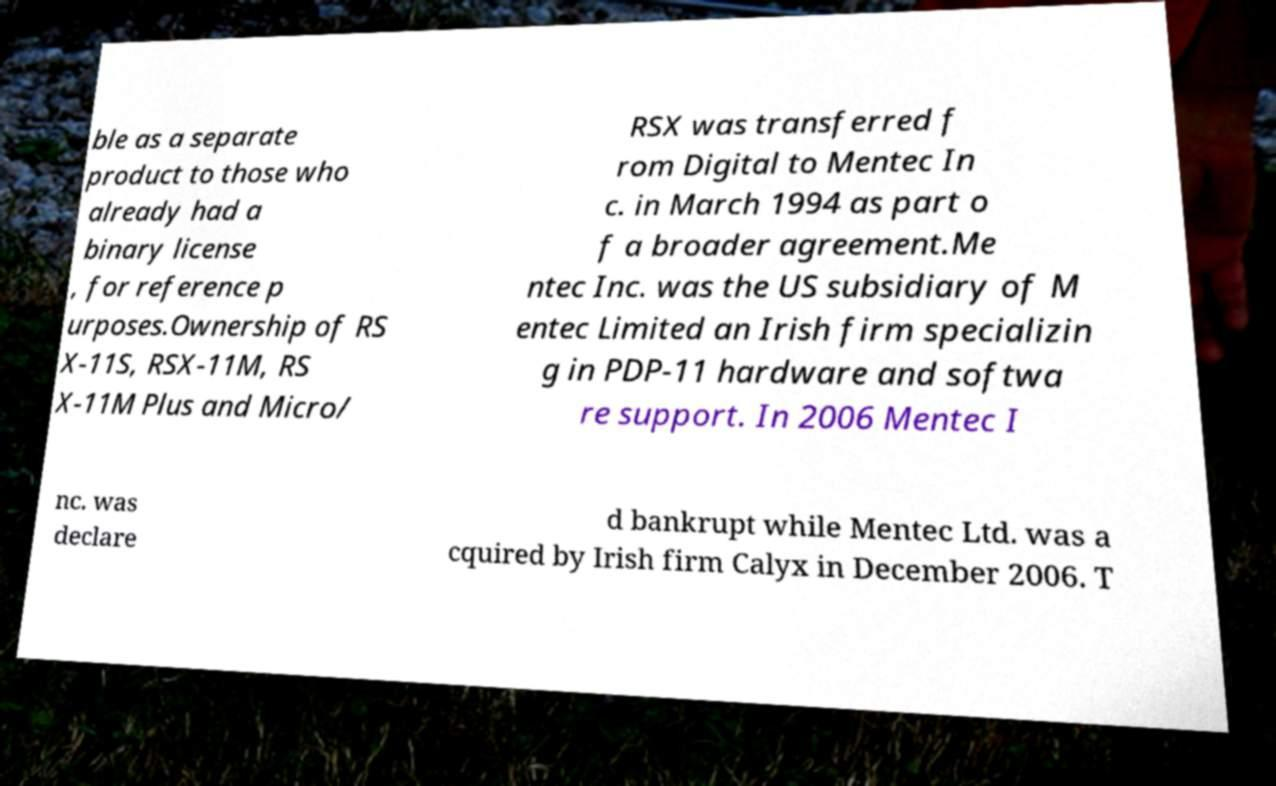Can you accurately transcribe the text from the provided image for me? ble as a separate product to those who already had a binary license , for reference p urposes.Ownership of RS X-11S, RSX-11M, RS X-11M Plus and Micro/ RSX was transferred f rom Digital to Mentec In c. in March 1994 as part o f a broader agreement.Me ntec Inc. was the US subsidiary of M entec Limited an Irish firm specializin g in PDP-11 hardware and softwa re support. In 2006 Mentec I nc. was declare d bankrupt while Mentec Ltd. was a cquired by Irish firm Calyx in December 2006. T 